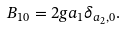Convert formula to latex. <formula><loc_0><loc_0><loc_500><loc_500>B _ { 1 0 } = 2 g a _ { 1 } \delta _ { a _ { 2 } , 0 } .</formula> 